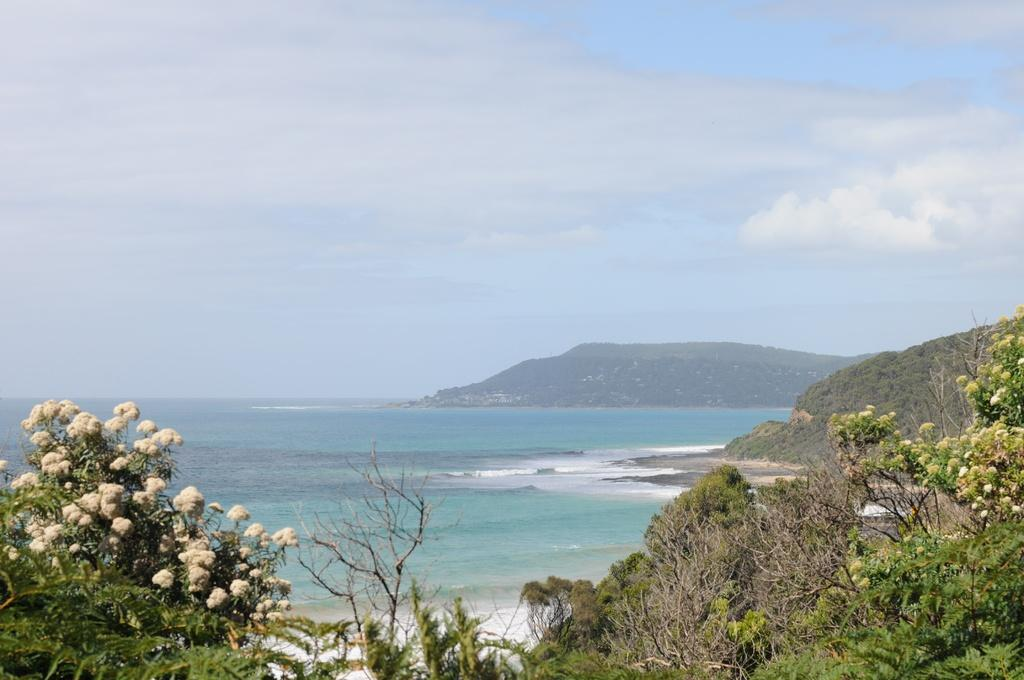What type of natural feature is the main subject of the image? There is an ocean in the image. What other natural elements can be seen at the bottom of the image? There are plants and trees at the bottom of the image. What type of landform is visible in the background of the image? There is a mountain in the background of the image. What part of the sky is visible in the image? The sky is visible at the top of the image. What atmospheric feature can be seen in the sky? Clouds are present in the sky. How many bikes are parked on the brick path near the ocean in the image? There are no bikes or brick paths present in the image; it features an ocean, plants, trees, a mountain, and the sky. 